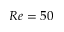Convert formula to latex. <formula><loc_0><loc_0><loc_500><loc_500>R e = 5 0</formula> 